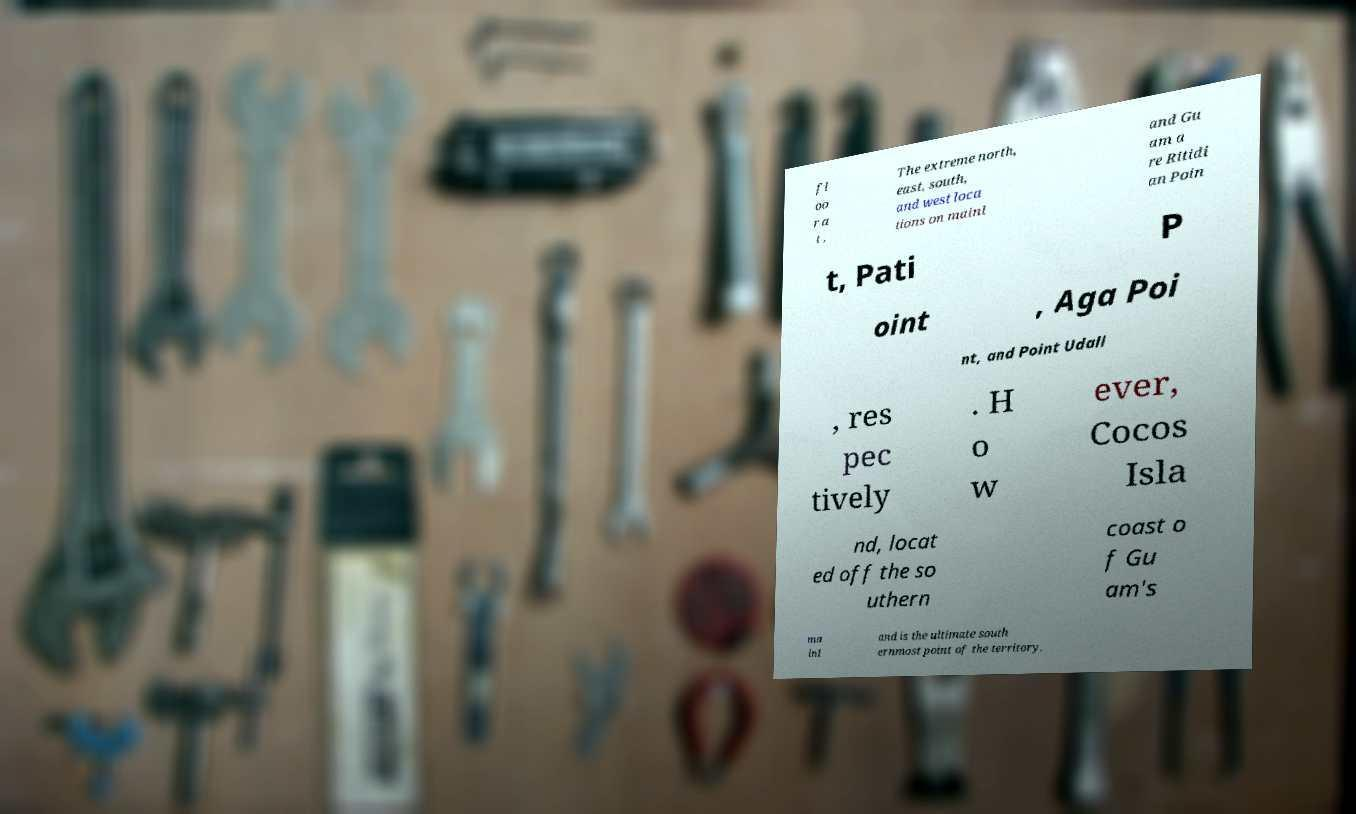For documentation purposes, I need the text within this image transcribed. Could you provide that? fl oo r a t . The extreme north, east, south, and west loca tions on mainl and Gu am a re Ritidi an Poin t, Pati P oint , Aga Poi nt, and Point Udall , res pec tively . H o w ever, Cocos Isla nd, locat ed off the so uthern coast o f Gu am's ma inl and is the ultimate south ernmost point of the territory. 